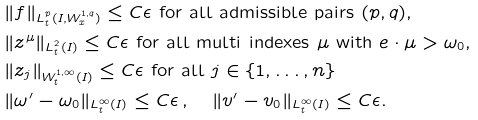<formula> <loc_0><loc_0><loc_500><loc_500>& \| f \| _ { L ^ { p } _ { t } ( I , W ^ { 1 , q } _ { x } ) } \leq C \epsilon \text { for all admissible pairs $(p,q)$,} \\ & \| z ^ { \mu } \| _ { L ^ { 2 } _ { t } ( I ) } \leq C \epsilon \text { for all multi indexes $\mu$  with $e\cdot \mu >\omega _{0} $,} \\ & \| z _ { j } \| _ { W ^ { 1 , \infty } _ { t } ( I ) } \leq C \epsilon \text { for all  $j\in \{ 1, \dots , n\}$ } \\ & \| \omega ^ { \prime } - \omega _ { 0 } \| _ { L _ { t } ^ { \infty } ( I ) } \leq C \epsilon \, , \quad \| v ^ { \prime } - v _ { 0 } \| _ { L ^ { \infty } _ { t } ( I ) } \leq C \epsilon .</formula> 